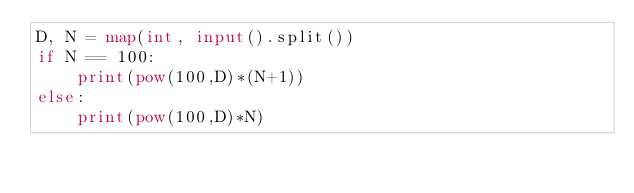Convert code to text. <code><loc_0><loc_0><loc_500><loc_500><_Python_>D, N = map(int, input().split())
if N == 100:
    print(pow(100,D)*(N+1))
else:
    print(pow(100,D)*N)
</code> 